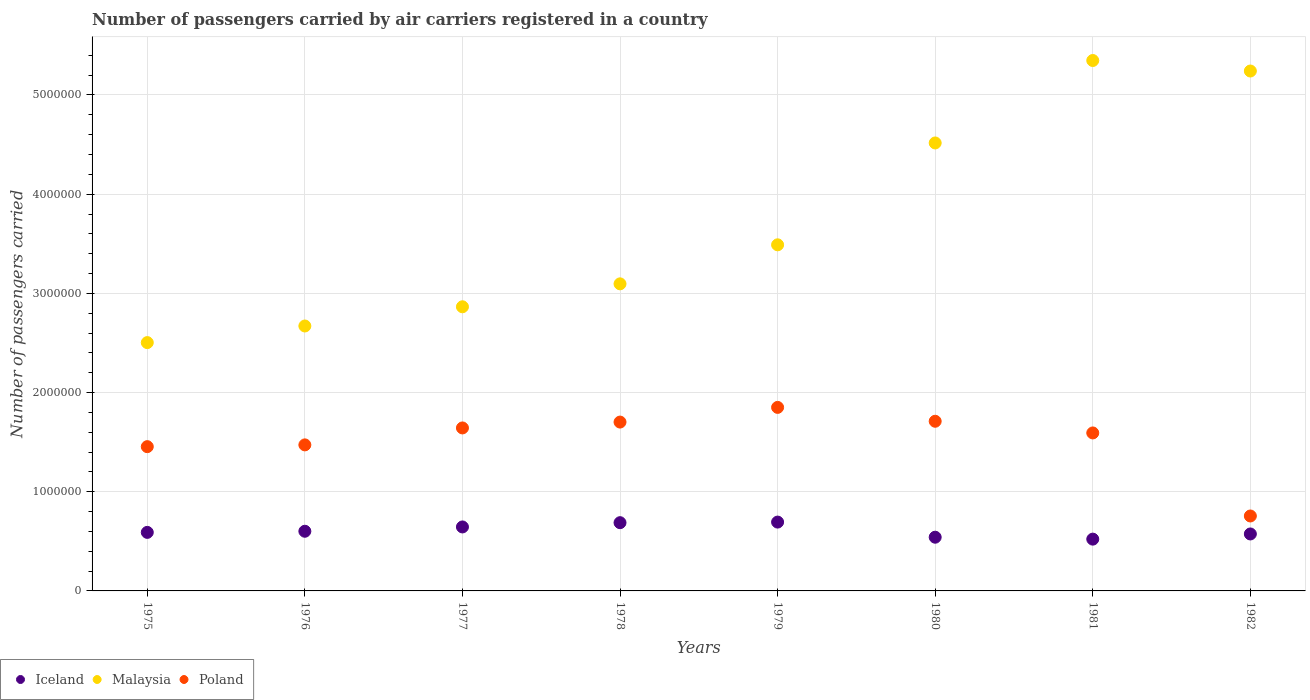What is the number of passengers carried by air carriers in Poland in 1982?
Make the answer very short. 7.56e+05. Across all years, what is the maximum number of passengers carried by air carriers in Poland?
Offer a very short reply. 1.85e+06. Across all years, what is the minimum number of passengers carried by air carriers in Malaysia?
Offer a very short reply. 2.50e+06. In which year was the number of passengers carried by air carriers in Malaysia minimum?
Offer a very short reply. 1975. What is the total number of passengers carried by air carriers in Poland in the graph?
Your answer should be very brief. 1.22e+07. What is the difference between the number of passengers carried by air carriers in Iceland in 1979 and that in 1981?
Make the answer very short. 1.72e+05. What is the difference between the number of passengers carried by air carriers in Malaysia in 1975 and the number of passengers carried by air carriers in Iceland in 1981?
Give a very brief answer. 1.98e+06. What is the average number of passengers carried by air carriers in Malaysia per year?
Offer a very short reply. 3.72e+06. In the year 1979, what is the difference between the number of passengers carried by air carriers in Iceland and number of passengers carried by air carriers in Malaysia?
Provide a short and direct response. -2.80e+06. What is the ratio of the number of passengers carried by air carriers in Poland in 1977 to that in 1979?
Offer a very short reply. 0.89. What is the difference between the highest and the second highest number of passengers carried by air carriers in Iceland?
Offer a very short reply. 6000. What is the difference between the highest and the lowest number of passengers carried by air carriers in Iceland?
Keep it short and to the point. 1.72e+05. Does the number of passengers carried by air carriers in Malaysia monotonically increase over the years?
Provide a short and direct response. No. Is the number of passengers carried by air carriers in Poland strictly greater than the number of passengers carried by air carriers in Iceland over the years?
Offer a terse response. Yes. Is the number of passengers carried by air carriers in Poland strictly less than the number of passengers carried by air carriers in Iceland over the years?
Your response must be concise. No. How many dotlines are there?
Your answer should be very brief. 3. What is the difference between two consecutive major ticks on the Y-axis?
Keep it short and to the point. 1.00e+06. Are the values on the major ticks of Y-axis written in scientific E-notation?
Your response must be concise. No. How many legend labels are there?
Offer a terse response. 3. How are the legend labels stacked?
Your answer should be compact. Horizontal. What is the title of the graph?
Keep it short and to the point. Number of passengers carried by air carriers registered in a country. What is the label or title of the Y-axis?
Make the answer very short. Number of passengers carried. What is the Number of passengers carried of Iceland in 1975?
Your answer should be very brief. 5.90e+05. What is the Number of passengers carried of Malaysia in 1975?
Your answer should be very brief. 2.50e+06. What is the Number of passengers carried in Poland in 1975?
Offer a terse response. 1.45e+06. What is the Number of passengers carried of Iceland in 1976?
Keep it short and to the point. 6.02e+05. What is the Number of passengers carried of Malaysia in 1976?
Provide a succinct answer. 2.67e+06. What is the Number of passengers carried of Poland in 1976?
Keep it short and to the point. 1.47e+06. What is the Number of passengers carried of Iceland in 1977?
Your answer should be very brief. 6.45e+05. What is the Number of passengers carried of Malaysia in 1977?
Offer a very short reply. 2.86e+06. What is the Number of passengers carried of Poland in 1977?
Your answer should be very brief. 1.64e+06. What is the Number of passengers carried of Iceland in 1978?
Give a very brief answer. 6.88e+05. What is the Number of passengers carried of Malaysia in 1978?
Provide a succinct answer. 3.10e+06. What is the Number of passengers carried in Poland in 1978?
Keep it short and to the point. 1.70e+06. What is the Number of passengers carried in Iceland in 1979?
Your answer should be very brief. 6.94e+05. What is the Number of passengers carried in Malaysia in 1979?
Ensure brevity in your answer.  3.49e+06. What is the Number of passengers carried in Poland in 1979?
Offer a terse response. 1.85e+06. What is the Number of passengers carried in Iceland in 1980?
Provide a short and direct response. 5.42e+05. What is the Number of passengers carried in Malaysia in 1980?
Give a very brief answer. 4.52e+06. What is the Number of passengers carried of Poland in 1980?
Your answer should be very brief. 1.71e+06. What is the Number of passengers carried in Iceland in 1981?
Make the answer very short. 5.22e+05. What is the Number of passengers carried of Malaysia in 1981?
Provide a succinct answer. 5.35e+06. What is the Number of passengers carried in Poland in 1981?
Your answer should be compact. 1.59e+06. What is the Number of passengers carried in Iceland in 1982?
Your answer should be very brief. 5.74e+05. What is the Number of passengers carried of Malaysia in 1982?
Your answer should be very brief. 5.24e+06. What is the Number of passengers carried in Poland in 1982?
Provide a succinct answer. 7.56e+05. Across all years, what is the maximum Number of passengers carried in Iceland?
Keep it short and to the point. 6.94e+05. Across all years, what is the maximum Number of passengers carried of Malaysia?
Your response must be concise. 5.35e+06. Across all years, what is the maximum Number of passengers carried of Poland?
Your answer should be very brief. 1.85e+06. Across all years, what is the minimum Number of passengers carried of Iceland?
Provide a short and direct response. 5.22e+05. Across all years, what is the minimum Number of passengers carried in Malaysia?
Your answer should be compact. 2.50e+06. Across all years, what is the minimum Number of passengers carried in Poland?
Give a very brief answer. 7.56e+05. What is the total Number of passengers carried in Iceland in the graph?
Your answer should be compact. 4.86e+06. What is the total Number of passengers carried of Malaysia in the graph?
Your answer should be very brief. 2.97e+07. What is the total Number of passengers carried of Poland in the graph?
Your response must be concise. 1.22e+07. What is the difference between the Number of passengers carried in Iceland in 1975 and that in 1976?
Your answer should be very brief. -1.13e+04. What is the difference between the Number of passengers carried of Malaysia in 1975 and that in 1976?
Make the answer very short. -1.67e+05. What is the difference between the Number of passengers carried of Poland in 1975 and that in 1976?
Ensure brevity in your answer.  -1.79e+04. What is the difference between the Number of passengers carried in Iceland in 1975 and that in 1977?
Your answer should be compact. -5.48e+04. What is the difference between the Number of passengers carried of Malaysia in 1975 and that in 1977?
Provide a succinct answer. -3.61e+05. What is the difference between the Number of passengers carried of Poland in 1975 and that in 1977?
Ensure brevity in your answer.  -1.89e+05. What is the difference between the Number of passengers carried in Iceland in 1975 and that in 1978?
Keep it short and to the point. -9.78e+04. What is the difference between the Number of passengers carried in Malaysia in 1975 and that in 1978?
Your answer should be very brief. -5.92e+05. What is the difference between the Number of passengers carried of Poland in 1975 and that in 1978?
Your response must be concise. -2.48e+05. What is the difference between the Number of passengers carried in Iceland in 1975 and that in 1979?
Provide a short and direct response. -1.04e+05. What is the difference between the Number of passengers carried in Malaysia in 1975 and that in 1979?
Make the answer very short. -9.86e+05. What is the difference between the Number of passengers carried of Poland in 1975 and that in 1979?
Keep it short and to the point. -3.96e+05. What is the difference between the Number of passengers carried in Iceland in 1975 and that in 1980?
Your response must be concise. 4.87e+04. What is the difference between the Number of passengers carried in Malaysia in 1975 and that in 1980?
Provide a succinct answer. -2.01e+06. What is the difference between the Number of passengers carried of Poland in 1975 and that in 1980?
Your response must be concise. -2.56e+05. What is the difference between the Number of passengers carried of Iceland in 1975 and that in 1981?
Your response must be concise. 6.81e+04. What is the difference between the Number of passengers carried of Malaysia in 1975 and that in 1981?
Your answer should be compact. -2.84e+06. What is the difference between the Number of passengers carried in Poland in 1975 and that in 1981?
Your answer should be very brief. -1.38e+05. What is the difference between the Number of passengers carried in Iceland in 1975 and that in 1982?
Provide a short and direct response. 1.59e+04. What is the difference between the Number of passengers carried of Malaysia in 1975 and that in 1982?
Provide a short and direct response. -2.74e+06. What is the difference between the Number of passengers carried in Poland in 1975 and that in 1982?
Give a very brief answer. 6.99e+05. What is the difference between the Number of passengers carried of Iceland in 1976 and that in 1977?
Your response must be concise. -4.35e+04. What is the difference between the Number of passengers carried in Malaysia in 1976 and that in 1977?
Offer a terse response. -1.94e+05. What is the difference between the Number of passengers carried of Poland in 1976 and that in 1977?
Your response must be concise. -1.71e+05. What is the difference between the Number of passengers carried in Iceland in 1976 and that in 1978?
Offer a terse response. -8.65e+04. What is the difference between the Number of passengers carried of Malaysia in 1976 and that in 1978?
Your response must be concise. -4.25e+05. What is the difference between the Number of passengers carried of Poland in 1976 and that in 1978?
Your response must be concise. -2.30e+05. What is the difference between the Number of passengers carried in Iceland in 1976 and that in 1979?
Your answer should be very brief. -9.25e+04. What is the difference between the Number of passengers carried in Malaysia in 1976 and that in 1979?
Provide a succinct answer. -8.18e+05. What is the difference between the Number of passengers carried of Poland in 1976 and that in 1979?
Your answer should be very brief. -3.78e+05. What is the difference between the Number of passengers carried in Malaysia in 1976 and that in 1980?
Provide a short and direct response. -1.85e+06. What is the difference between the Number of passengers carried of Poland in 1976 and that in 1980?
Offer a very short reply. -2.38e+05. What is the difference between the Number of passengers carried in Iceland in 1976 and that in 1981?
Keep it short and to the point. 7.94e+04. What is the difference between the Number of passengers carried in Malaysia in 1976 and that in 1981?
Provide a short and direct response. -2.68e+06. What is the difference between the Number of passengers carried of Poland in 1976 and that in 1981?
Your response must be concise. -1.20e+05. What is the difference between the Number of passengers carried of Iceland in 1976 and that in 1982?
Your answer should be compact. 2.72e+04. What is the difference between the Number of passengers carried of Malaysia in 1976 and that in 1982?
Make the answer very short. -2.57e+06. What is the difference between the Number of passengers carried of Poland in 1976 and that in 1982?
Give a very brief answer. 7.17e+05. What is the difference between the Number of passengers carried in Iceland in 1977 and that in 1978?
Ensure brevity in your answer.  -4.30e+04. What is the difference between the Number of passengers carried in Malaysia in 1977 and that in 1978?
Give a very brief answer. -2.31e+05. What is the difference between the Number of passengers carried in Poland in 1977 and that in 1978?
Offer a very short reply. -5.91e+04. What is the difference between the Number of passengers carried of Iceland in 1977 and that in 1979?
Your answer should be very brief. -4.90e+04. What is the difference between the Number of passengers carried of Malaysia in 1977 and that in 1979?
Make the answer very short. -6.25e+05. What is the difference between the Number of passengers carried of Poland in 1977 and that in 1979?
Give a very brief answer. -2.07e+05. What is the difference between the Number of passengers carried in Iceland in 1977 and that in 1980?
Ensure brevity in your answer.  1.04e+05. What is the difference between the Number of passengers carried of Malaysia in 1977 and that in 1980?
Give a very brief answer. -1.65e+06. What is the difference between the Number of passengers carried of Poland in 1977 and that in 1980?
Your answer should be compact. -6.73e+04. What is the difference between the Number of passengers carried in Iceland in 1977 and that in 1981?
Offer a terse response. 1.23e+05. What is the difference between the Number of passengers carried of Malaysia in 1977 and that in 1981?
Provide a short and direct response. -2.48e+06. What is the difference between the Number of passengers carried of Poland in 1977 and that in 1981?
Ensure brevity in your answer.  5.04e+04. What is the difference between the Number of passengers carried in Iceland in 1977 and that in 1982?
Ensure brevity in your answer.  7.07e+04. What is the difference between the Number of passengers carried in Malaysia in 1977 and that in 1982?
Your answer should be compact. -2.38e+06. What is the difference between the Number of passengers carried in Poland in 1977 and that in 1982?
Your answer should be compact. 8.88e+05. What is the difference between the Number of passengers carried in Iceland in 1978 and that in 1979?
Offer a very short reply. -6000. What is the difference between the Number of passengers carried in Malaysia in 1978 and that in 1979?
Offer a very short reply. -3.94e+05. What is the difference between the Number of passengers carried in Poland in 1978 and that in 1979?
Provide a succinct answer. -1.48e+05. What is the difference between the Number of passengers carried of Iceland in 1978 and that in 1980?
Your answer should be very brief. 1.46e+05. What is the difference between the Number of passengers carried of Malaysia in 1978 and that in 1980?
Offer a very short reply. -1.42e+06. What is the difference between the Number of passengers carried of Poland in 1978 and that in 1980?
Offer a very short reply. -8200. What is the difference between the Number of passengers carried in Iceland in 1978 and that in 1981?
Ensure brevity in your answer.  1.66e+05. What is the difference between the Number of passengers carried in Malaysia in 1978 and that in 1981?
Give a very brief answer. -2.25e+06. What is the difference between the Number of passengers carried of Poland in 1978 and that in 1981?
Offer a terse response. 1.10e+05. What is the difference between the Number of passengers carried of Iceland in 1978 and that in 1982?
Offer a very short reply. 1.14e+05. What is the difference between the Number of passengers carried in Malaysia in 1978 and that in 1982?
Ensure brevity in your answer.  -2.15e+06. What is the difference between the Number of passengers carried in Poland in 1978 and that in 1982?
Offer a terse response. 9.47e+05. What is the difference between the Number of passengers carried of Iceland in 1979 and that in 1980?
Provide a succinct answer. 1.52e+05. What is the difference between the Number of passengers carried of Malaysia in 1979 and that in 1980?
Make the answer very short. -1.03e+06. What is the difference between the Number of passengers carried of Poland in 1979 and that in 1980?
Keep it short and to the point. 1.40e+05. What is the difference between the Number of passengers carried in Iceland in 1979 and that in 1981?
Provide a succinct answer. 1.72e+05. What is the difference between the Number of passengers carried of Malaysia in 1979 and that in 1981?
Provide a succinct answer. -1.86e+06. What is the difference between the Number of passengers carried of Poland in 1979 and that in 1981?
Offer a terse response. 2.58e+05. What is the difference between the Number of passengers carried in Iceland in 1979 and that in 1982?
Provide a succinct answer. 1.20e+05. What is the difference between the Number of passengers carried in Malaysia in 1979 and that in 1982?
Give a very brief answer. -1.75e+06. What is the difference between the Number of passengers carried in Poland in 1979 and that in 1982?
Keep it short and to the point. 1.09e+06. What is the difference between the Number of passengers carried of Iceland in 1980 and that in 1981?
Ensure brevity in your answer.  1.94e+04. What is the difference between the Number of passengers carried in Malaysia in 1980 and that in 1981?
Provide a succinct answer. -8.31e+05. What is the difference between the Number of passengers carried in Poland in 1980 and that in 1981?
Your response must be concise. 1.18e+05. What is the difference between the Number of passengers carried in Iceland in 1980 and that in 1982?
Keep it short and to the point. -3.28e+04. What is the difference between the Number of passengers carried in Malaysia in 1980 and that in 1982?
Your answer should be very brief. -7.25e+05. What is the difference between the Number of passengers carried in Poland in 1980 and that in 1982?
Provide a succinct answer. 9.55e+05. What is the difference between the Number of passengers carried in Iceland in 1981 and that in 1982?
Ensure brevity in your answer.  -5.22e+04. What is the difference between the Number of passengers carried in Malaysia in 1981 and that in 1982?
Your answer should be compact. 1.06e+05. What is the difference between the Number of passengers carried in Poland in 1981 and that in 1982?
Your response must be concise. 8.37e+05. What is the difference between the Number of passengers carried of Iceland in 1975 and the Number of passengers carried of Malaysia in 1976?
Your answer should be very brief. -2.08e+06. What is the difference between the Number of passengers carried in Iceland in 1975 and the Number of passengers carried in Poland in 1976?
Offer a terse response. -8.82e+05. What is the difference between the Number of passengers carried in Malaysia in 1975 and the Number of passengers carried in Poland in 1976?
Keep it short and to the point. 1.03e+06. What is the difference between the Number of passengers carried in Iceland in 1975 and the Number of passengers carried in Malaysia in 1977?
Ensure brevity in your answer.  -2.27e+06. What is the difference between the Number of passengers carried of Iceland in 1975 and the Number of passengers carried of Poland in 1977?
Provide a short and direct response. -1.05e+06. What is the difference between the Number of passengers carried of Malaysia in 1975 and the Number of passengers carried of Poland in 1977?
Give a very brief answer. 8.60e+05. What is the difference between the Number of passengers carried in Iceland in 1975 and the Number of passengers carried in Malaysia in 1978?
Make the answer very short. -2.51e+06. What is the difference between the Number of passengers carried in Iceland in 1975 and the Number of passengers carried in Poland in 1978?
Your answer should be very brief. -1.11e+06. What is the difference between the Number of passengers carried in Malaysia in 1975 and the Number of passengers carried in Poland in 1978?
Offer a very short reply. 8.01e+05. What is the difference between the Number of passengers carried in Iceland in 1975 and the Number of passengers carried in Malaysia in 1979?
Offer a terse response. -2.90e+06. What is the difference between the Number of passengers carried of Iceland in 1975 and the Number of passengers carried of Poland in 1979?
Make the answer very short. -1.26e+06. What is the difference between the Number of passengers carried in Malaysia in 1975 and the Number of passengers carried in Poland in 1979?
Ensure brevity in your answer.  6.53e+05. What is the difference between the Number of passengers carried of Iceland in 1975 and the Number of passengers carried of Malaysia in 1980?
Ensure brevity in your answer.  -3.93e+06. What is the difference between the Number of passengers carried of Iceland in 1975 and the Number of passengers carried of Poland in 1980?
Make the answer very short. -1.12e+06. What is the difference between the Number of passengers carried in Malaysia in 1975 and the Number of passengers carried in Poland in 1980?
Your answer should be very brief. 7.93e+05. What is the difference between the Number of passengers carried in Iceland in 1975 and the Number of passengers carried in Malaysia in 1981?
Your answer should be very brief. -4.76e+06. What is the difference between the Number of passengers carried in Iceland in 1975 and the Number of passengers carried in Poland in 1981?
Your answer should be compact. -1.00e+06. What is the difference between the Number of passengers carried in Malaysia in 1975 and the Number of passengers carried in Poland in 1981?
Make the answer very short. 9.11e+05. What is the difference between the Number of passengers carried in Iceland in 1975 and the Number of passengers carried in Malaysia in 1982?
Give a very brief answer. -4.65e+06. What is the difference between the Number of passengers carried of Iceland in 1975 and the Number of passengers carried of Poland in 1982?
Offer a very short reply. -1.65e+05. What is the difference between the Number of passengers carried of Malaysia in 1975 and the Number of passengers carried of Poland in 1982?
Ensure brevity in your answer.  1.75e+06. What is the difference between the Number of passengers carried of Iceland in 1976 and the Number of passengers carried of Malaysia in 1977?
Provide a succinct answer. -2.26e+06. What is the difference between the Number of passengers carried of Iceland in 1976 and the Number of passengers carried of Poland in 1977?
Keep it short and to the point. -1.04e+06. What is the difference between the Number of passengers carried of Malaysia in 1976 and the Number of passengers carried of Poland in 1977?
Your response must be concise. 1.03e+06. What is the difference between the Number of passengers carried in Iceland in 1976 and the Number of passengers carried in Malaysia in 1978?
Make the answer very short. -2.49e+06. What is the difference between the Number of passengers carried of Iceland in 1976 and the Number of passengers carried of Poland in 1978?
Your answer should be very brief. -1.10e+06. What is the difference between the Number of passengers carried in Malaysia in 1976 and the Number of passengers carried in Poland in 1978?
Your answer should be very brief. 9.69e+05. What is the difference between the Number of passengers carried in Iceland in 1976 and the Number of passengers carried in Malaysia in 1979?
Your answer should be very brief. -2.89e+06. What is the difference between the Number of passengers carried in Iceland in 1976 and the Number of passengers carried in Poland in 1979?
Your response must be concise. -1.25e+06. What is the difference between the Number of passengers carried of Malaysia in 1976 and the Number of passengers carried of Poland in 1979?
Provide a short and direct response. 8.21e+05. What is the difference between the Number of passengers carried in Iceland in 1976 and the Number of passengers carried in Malaysia in 1980?
Provide a short and direct response. -3.91e+06. What is the difference between the Number of passengers carried of Iceland in 1976 and the Number of passengers carried of Poland in 1980?
Offer a very short reply. -1.11e+06. What is the difference between the Number of passengers carried of Malaysia in 1976 and the Number of passengers carried of Poland in 1980?
Your answer should be very brief. 9.60e+05. What is the difference between the Number of passengers carried of Iceland in 1976 and the Number of passengers carried of Malaysia in 1981?
Your answer should be very brief. -4.75e+06. What is the difference between the Number of passengers carried in Iceland in 1976 and the Number of passengers carried in Poland in 1981?
Offer a very short reply. -9.91e+05. What is the difference between the Number of passengers carried in Malaysia in 1976 and the Number of passengers carried in Poland in 1981?
Provide a short and direct response. 1.08e+06. What is the difference between the Number of passengers carried of Iceland in 1976 and the Number of passengers carried of Malaysia in 1982?
Provide a succinct answer. -4.64e+06. What is the difference between the Number of passengers carried of Iceland in 1976 and the Number of passengers carried of Poland in 1982?
Your response must be concise. -1.54e+05. What is the difference between the Number of passengers carried in Malaysia in 1976 and the Number of passengers carried in Poland in 1982?
Make the answer very short. 1.92e+06. What is the difference between the Number of passengers carried of Iceland in 1977 and the Number of passengers carried of Malaysia in 1978?
Your response must be concise. -2.45e+06. What is the difference between the Number of passengers carried in Iceland in 1977 and the Number of passengers carried in Poland in 1978?
Give a very brief answer. -1.06e+06. What is the difference between the Number of passengers carried of Malaysia in 1977 and the Number of passengers carried of Poland in 1978?
Ensure brevity in your answer.  1.16e+06. What is the difference between the Number of passengers carried of Iceland in 1977 and the Number of passengers carried of Malaysia in 1979?
Make the answer very short. -2.84e+06. What is the difference between the Number of passengers carried of Iceland in 1977 and the Number of passengers carried of Poland in 1979?
Provide a short and direct response. -1.21e+06. What is the difference between the Number of passengers carried in Malaysia in 1977 and the Number of passengers carried in Poland in 1979?
Provide a succinct answer. 1.01e+06. What is the difference between the Number of passengers carried in Iceland in 1977 and the Number of passengers carried in Malaysia in 1980?
Make the answer very short. -3.87e+06. What is the difference between the Number of passengers carried of Iceland in 1977 and the Number of passengers carried of Poland in 1980?
Your response must be concise. -1.07e+06. What is the difference between the Number of passengers carried in Malaysia in 1977 and the Number of passengers carried in Poland in 1980?
Keep it short and to the point. 1.15e+06. What is the difference between the Number of passengers carried in Iceland in 1977 and the Number of passengers carried in Malaysia in 1981?
Give a very brief answer. -4.70e+06. What is the difference between the Number of passengers carried of Iceland in 1977 and the Number of passengers carried of Poland in 1981?
Make the answer very short. -9.48e+05. What is the difference between the Number of passengers carried in Malaysia in 1977 and the Number of passengers carried in Poland in 1981?
Offer a terse response. 1.27e+06. What is the difference between the Number of passengers carried of Iceland in 1977 and the Number of passengers carried of Malaysia in 1982?
Offer a terse response. -4.60e+06. What is the difference between the Number of passengers carried of Iceland in 1977 and the Number of passengers carried of Poland in 1982?
Offer a terse response. -1.10e+05. What is the difference between the Number of passengers carried in Malaysia in 1977 and the Number of passengers carried in Poland in 1982?
Your response must be concise. 2.11e+06. What is the difference between the Number of passengers carried of Iceland in 1978 and the Number of passengers carried of Malaysia in 1979?
Your answer should be compact. -2.80e+06. What is the difference between the Number of passengers carried of Iceland in 1978 and the Number of passengers carried of Poland in 1979?
Offer a terse response. -1.16e+06. What is the difference between the Number of passengers carried in Malaysia in 1978 and the Number of passengers carried in Poland in 1979?
Your answer should be compact. 1.25e+06. What is the difference between the Number of passengers carried in Iceland in 1978 and the Number of passengers carried in Malaysia in 1980?
Provide a succinct answer. -3.83e+06. What is the difference between the Number of passengers carried of Iceland in 1978 and the Number of passengers carried of Poland in 1980?
Give a very brief answer. -1.02e+06. What is the difference between the Number of passengers carried in Malaysia in 1978 and the Number of passengers carried in Poland in 1980?
Make the answer very short. 1.39e+06. What is the difference between the Number of passengers carried of Iceland in 1978 and the Number of passengers carried of Malaysia in 1981?
Your answer should be compact. -4.66e+06. What is the difference between the Number of passengers carried in Iceland in 1978 and the Number of passengers carried in Poland in 1981?
Provide a short and direct response. -9.05e+05. What is the difference between the Number of passengers carried of Malaysia in 1978 and the Number of passengers carried of Poland in 1981?
Ensure brevity in your answer.  1.50e+06. What is the difference between the Number of passengers carried of Iceland in 1978 and the Number of passengers carried of Malaysia in 1982?
Your response must be concise. -4.55e+06. What is the difference between the Number of passengers carried in Iceland in 1978 and the Number of passengers carried in Poland in 1982?
Make the answer very short. -6.75e+04. What is the difference between the Number of passengers carried in Malaysia in 1978 and the Number of passengers carried in Poland in 1982?
Ensure brevity in your answer.  2.34e+06. What is the difference between the Number of passengers carried of Iceland in 1979 and the Number of passengers carried of Malaysia in 1980?
Provide a short and direct response. -3.82e+06. What is the difference between the Number of passengers carried in Iceland in 1979 and the Number of passengers carried in Poland in 1980?
Your response must be concise. -1.02e+06. What is the difference between the Number of passengers carried in Malaysia in 1979 and the Number of passengers carried in Poland in 1980?
Provide a succinct answer. 1.78e+06. What is the difference between the Number of passengers carried of Iceland in 1979 and the Number of passengers carried of Malaysia in 1981?
Your response must be concise. -4.65e+06. What is the difference between the Number of passengers carried of Iceland in 1979 and the Number of passengers carried of Poland in 1981?
Offer a very short reply. -8.99e+05. What is the difference between the Number of passengers carried of Malaysia in 1979 and the Number of passengers carried of Poland in 1981?
Give a very brief answer. 1.90e+06. What is the difference between the Number of passengers carried of Iceland in 1979 and the Number of passengers carried of Malaysia in 1982?
Provide a short and direct response. -4.55e+06. What is the difference between the Number of passengers carried in Iceland in 1979 and the Number of passengers carried in Poland in 1982?
Your answer should be very brief. -6.15e+04. What is the difference between the Number of passengers carried in Malaysia in 1979 and the Number of passengers carried in Poland in 1982?
Your answer should be very brief. 2.73e+06. What is the difference between the Number of passengers carried of Iceland in 1980 and the Number of passengers carried of Malaysia in 1981?
Your answer should be very brief. -4.81e+06. What is the difference between the Number of passengers carried in Iceland in 1980 and the Number of passengers carried in Poland in 1981?
Offer a very short reply. -1.05e+06. What is the difference between the Number of passengers carried in Malaysia in 1980 and the Number of passengers carried in Poland in 1981?
Offer a very short reply. 2.92e+06. What is the difference between the Number of passengers carried of Iceland in 1980 and the Number of passengers carried of Malaysia in 1982?
Give a very brief answer. -4.70e+06. What is the difference between the Number of passengers carried of Iceland in 1980 and the Number of passengers carried of Poland in 1982?
Ensure brevity in your answer.  -2.14e+05. What is the difference between the Number of passengers carried of Malaysia in 1980 and the Number of passengers carried of Poland in 1982?
Give a very brief answer. 3.76e+06. What is the difference between the Number of passengers carried in Iceland in 1981 and the Number of passengers carried in Malaysia in 1982?
Offer a terse response. -4.72e+06. What is the difference between the Number of passengers carried in Iceland in 1981 and the Number of passengers carried in Poland in 1982?
Make the answer very short. -2.33e+05. What is the difference between the Number of passengers carried in Malaysia in 1981 and the Number of passengers carried in Poland in 1982?
Provide a short and direct response. 4.59e+06. What is the average Number of passengers carried of Iceland per year?
Ensure brevity in your answer.  6.07e+05. What is the average Number of passengers carried of Malaysia per year?
Provide a succinct answer. 3.72e+06. What is the average Number of passengers carried of Poland per year?
Your answer should be very brief. 1.52e+06. In the year 1975, what is the difference between the Number of passengers carried of Iceland and Number of passengers carried of Malaysia?
Your answer should be compact. -1.91e+06. In the year 1975, what is the difference between the Number of passengers carried of Iceland and Number of passengers carried of Poland?
Your answer should be compact. -8.64e+05. In the year 1975, what is the difference between the Number of passengers carried in Malaysia and Number of passengers carried in Poland?
Offer a very short reply. 1.05e+06. In the year 1976, what is the difference between the Number of passengers carried in Iceland and Number of passengers carried in Malaysia?
Your response must be concise. -2.07e+06. In the year 1976, what is the difference between the Number of passengers carried of Iceland and Number of passengers carried of Poland?
Your response must be concise. -8.71e+05. In the year 1976, what is the difference between the Number of passengers carried of Malaysia and Number of passengers carried of Poland?
Offer a very short reply. 1.20e+06. In the year 1977, what is the difference between the Number of passengers carried of Iceland and Number of passengers carried of Malaysia?
Make the answer very short. -2.22e+06. In the year 1977, what is the difference between the Number of passengers carried of Iceland and Number of passengers carried of Poland?
Offer a terse response. -9.98e+05. In the year 1977, what is the difference between the Number of passengers carried in Malaysia and Number of passengers carried in Poland?
Offer a very short reply. 1.22e+06. In the year 1978, what is the difference between the Number of passengers carried of Iceland and Number of passengers carried of Malaysia?
Provide a short and direct response. -2.41e+06. In the year 1978, what is the difference between the Number of passengers carried in Iceland and Number of passengers carried in Poland?
Keep it short and to the point. -1.01e+06. In the year 1978, what is the difference between the Number of passengers carried in Malaysia and Number of passengers carried in Poland?
Provide a succinct answer. 1.39e+06. In the year 1979, what is the difference between the Number of passengers carried of Iceland and Number of passengers carried of Malaysia?
Provide a succinct answer. -2.80e+06. In the year 1979, what is the difference between the Number of passengers carried in Iceland and Number of passengers carried in Poland?
Offer a terse response. -1.16e+06. In the year 1979, what is the difference between the Number of passengers carried in Malaysia and Number of passengers carried in Poland?
Provide a short and direct response. 1.64e+06. In the year 1980, what is the difference between the Number of passengers carried in Iceland and Number of passengers carried in Malaysia?
Your answer should be compact. -3.97e+06. In the year 1980, what is the difference between the Number of passengers carried in Iceland and Number of passengers carried in Poland?
Keep it short and to the point. -1.17e+06. In the year 1980, what is the difference between the Number of passengers carried of Malaysia and Number of passengers carried of Poland?
Offer a very short reply. 2.81e+06. In the year 1981, what is the difference between the Number of passengers carried in Iceland and Number of passengers carried in Malaysia?
Offer a terse response. -4.83e+06. In the year 1981, what is the difference between the Number of passengers carried in Iceland and Number of passengers carried in Poland?
Provide a short and direct response. -1.07e+06. In the year 1981, what is the difference between the Number of passengers carried in Malaysia and Number of passengers carried in Poland?
Offer a very short reply. 3.75e+06. In the year 1982, what is the difference between the Number of passengers carried in Iceland and Number of passengers carried in Malaysia?
Offer a very short reply. -4.67e+06. In the year 1982, what is the difference between the Number of passengers carried in Iceland and Number of passengers carried in Poland?
Your answer should be very brief. -1.81e+05. In the year 1982, what is the difference between the Number of passengers carried of Malaysia and Number of passengers carried of Poland?
Provide a short and direct response. 4.49e+06. What is the ratio of the Number of passengers carried in Iceland in 1975 to that in 1976?
Make the answer very short. 0.98. What is the ratio of the Number of passengers carried of Malaysia in 1975 to that in 1976?
Your answer should be compact. 0.94. What is the ratio of the Number of passengers carried in Poland in 1975 to that in 1976?
Give a very brief answer. 0.99. What is the ratio of the Number of passengers carried of Iceland in 1975 to that in 1977?
Offer a very short reply. 0.92. What is the ratio of the Number of passengers carried of Malaysia in 1975 to that in 1977?
Make the answer very short. 0.87. What is the ratio of the Number of passengers carried of Poland in 1975 to that in 1977?
Provide a short and direct response. 0.89. What is the ratio of the Number of passengers carried in Iceland in 1975 to that in 1978?
Give a very brief answer. 0.86. What is the ratio of the Number of passengers carried of Malaysia in 1975 to that in 1978?
Provide a succinct answer. 0.81. What is the ratio of the Number of passengers carried in Poland in 1975 to that in 1978?
Ensure brevity in your answer.  0.85. What is the ratio of the Number of passengers carried of Iceland in 1975 to that in 1979?
Give a very brief answer. 0.85. What is the ratio of the Number of passengers carried of Malaysia in 1975 to that in 1979?
Keep it short and to the point. 0.72. What is the ratio of the Number of passengers carried in Poland in 1975 to that in 1979?
Keep it short and to the point. 0.79. What is the ratio of the Number of passengers carried of Iceland in 1975 to that in 1980?
Provide a short and direct response. 1.09. What is the ratio of the Number of passengers carried of Malaysia in 1975 to that in 1980?
Your answer should be compact. 0.55. What is the ratio of the Number of passengers carried of Poland in 1975 to that in 1980?
Give a very brief answer. 0.85. What is the ratio of the Number of passengers carried of Iceland in 1975 to that in 1981?
Provide a short and direct response. 1.13. What is the ratio of the Number of passengers carried in Malaysia in 1975 to that in 1981?
Your answer should be compact. 0.47. What is the ratio of the Number of passengers carried in Poland in 1975 to that in 1981?
Your answer should be very brief. 0.91. What is the ratio of the Number of passengers carried in Iceland in 1975 to that in 1982?
Ensure brevity in your answer.  1.03. What is the ratio of the Number of passengers carried of Malaysia in 1975 to that in 1982?
Offer a terse response. 0.48. What is the ratio of the Number of passengers carried of Poland in 1975 to that in 1982?
Make the answer very short. 1.93. What is the ratio of the Number of passengers carried of Iceland in 1976 to that in 1977?
Make the answer very short. 0.93. What is the ratio of the Number of passengers carried in Malaysia in 1976 to that in 1977?
Provide a succinct answer. 0.93. What is the ratio of the Number of passengers carried of Poland in 1976 to that in 1977?
Your answer should be very brief. 0.9. What is the ratio of the Number of passengers carried of Iceland in 1976 to that in 1978?
Offer a terse response. 0.87. What is the ratio of the Number of passengers carried in Malaysia in 1976 to that in 1978?
Your response must be concise. 0.86. What is the ratio of the Number of passengers carried of Poland in 1976 to that in 1978?
Your response must be concise. 0.86. What is the ratio of the Number of passengers carried of Iceland in 1976 to that in 1979?
Offer a terse response. 0.87. What is the ratio of the Number of passengers carried in Malaysia in 1976 to that in 1979?
Ensure brevity in your answer.  0.77. What is the ratio of the Number of passengers carried of Poland in 1976 to that in 1979?
Offer a terse response. 0.8. What is the ratio of the Number of passengers carried in Iceland in 1976 to that in 1980?
Keep it short and to the point. 1.11. What is the ratio of the Number of passengers carried of Malaysia in 1976 to that in 1980?
Provide a succinct answer. 0.59. What is the ratio of the Number of passengers carried in Poland in 1976 to that in 1980?
Your response must be concise. 0.86. What is the ratio of the Number of passengers carried of Iceland in 1976 to that in 1981?
Provide a succinct answer. 1.15. What is the ratio of the Number of passengers carried in Malaysia in 1976 to that in 1981?
Provide a succinct answer. 0.5. What is the ratio of the Number of passengers carried of Poland in 1976 to that in 1981?
Ensure brevity in your answer.  0.92. What is the ratio of the Number of passengers carried in Iceland in 1976 to that in 1982?
Provide a succinct answer. 1.05. What is the ratio of the Number of passengers carried of Malaysia in 1976 to that in 1982?
Your answer should be very brief. 0.51. What is the ratio of the Number of passengers carried in Poland in 1976 to that in 1982?
Your answer should be compact. 1.95. What is the ratio of the Number of passengers carried in Iceland in 1977 to that in 1978?
Offer a very short reply. 0.94. What is the ratio of the Number of passengers carried of Malaysia in 1977 to that in 1978?
Offer a terse response. 0.93. What is the ratio of the Number of passengers carried in Poland in 1977 to that in 1978?
Offer a very short reply. 0.97. What is the ratio of the Number of passengers carried of Iceland in 1977 to that in 1979?
Provide a short and direct response. 0.93. What is the ratio of the Number of passengers carried in Malaysia in 1977 to that in 1979?
Offer a very short reply. 0.82. What is the ratio of the Number of passengers carried of Poland in 1977 to that in 1979?
Your answer should be compact. 0.89. What is the ratio of the Number of passengers carried of Iceland in 1977 to that in 1980?
Provide a succinct answer. 1.19. What is the ratio of the Number of passengers carried in Malaysia in 1977 to that in 1980?
Offer a very short reply. 0.63. What is the ratio of the Number of passengers carried in Poland in 1977 to that in 1980?
Your answer should be very brief. 0.96. What is the ratio of the Number of passengers carried of Iceland in 1977 to that in 1981?
Give a very brief answer. 1.24. What is the ratio of the Number of passengers carried of Malaysia in 1977 to that in 1981?
Give a very brief answer. 0.54. What is the ratio of the Number of passengers carried in Poland in 1977 to that in 1981?
Your answer should be very brief. 1.03. What is the ratio of the Number of passengers carried in Iceland in 1977 to that in 1982?
Your answer should be very brief. 1.12. What is the ratio of the Number of passengers carried of Malaysia in 1977 to that in 1982?
Provide a short and direct response. 0.55. What is the ratio of the Number of passengers carried of Poland in 1977 to that in 1982?
Offer a very short reply. 2.17. What is the ratio of the Number of passengers carried of Malaysia in 1978 to that in 1979?
Offer a terse response. 0.89. What is the ratio of the Number of passengers carried of Poland in 1978 to that in 1979?
Your answer should be very brief. 0.92. What is the ratio of the Number of passengers carried of Iceland in 1978 to that in 1980?
Your answer should be very brief. 1.27. What is the ratio of the Number of passengers carried in Malaysia in 1978 to that in 1980?
Provide a short and direct response. 0.69. What is the ratio of the Number of passengers carried in Iceland in 1978 to that in 1981?
Your response must be concise. 1.32. What is the ratio of the Number of passengers carried of Malaysia in 1978 to that in 1981?
Offer a very short reply. 0.58. What is the ratio of the Number of passengers carried of Poland in 1978 to that in 1981?
Your answer should be compact. 1.07. What is the ratio of the Number of passengers carried in Iceland in 1978 to that in 1982?
Provide a succinct answer. 1.2. What is the ratio of the Number of passengers carried in Malaysia in 1978 to that in 1982?
Make the answer very short. 0.59. What is the ratio of the Number of passengers carried in Poland in 1978 to that in 1982?
Provide a succinct answer. 2.25. What is the ratio of the Number of passengers carried in Iceland in 1979 to that in 1980?
Offer a very short reply. 1.28. What is the ratio of the Number of passengers carried in Malaysia in 1979 to that in 1980?
Offer a terse response. 0.77. What is the ratio of the Number of passengers carried in Poland in 1979 to that in 1980?
Your response must be concise. 1.08. What is the ratio of the Number of passengers carried of Iceland in 1979 to that in 1981?
Your response must be concise. 1.33. What is the ratio of the Number of passengers carried in Malaysia in 1979 to that in 1981?
Provide a short and direct response. 0.65. What is the ratio of the Number of passengers carried of Poland in 1979 to that in 1981?
Make the answer very short. 1.16. What is the ratio of the Number of passengers carried in Iceland in 1979 to that in 1982?
Make the answer very short. 1.21. What is the ratio of the Number of passengers carried of Malaysia in 1979 to that in 1982?
Provide a short and direct response. 0.67. What is the ratio of the Number of passengers carried of Poland in 1979 to that in 1982?
Give a very brief answer. 2.45. What is the ratio of the Number of passengers carried of Iceland in 1980 to that in 1981?
Your response must be concise. 1.04. What is the ratio of the Number of passengers carried of Malaysia in 1980 to that in 1981?
Offer a very short reply. 0.84. What is the ratio of the Number of passengers carried of Poland in 1980 to that in 1981?
Provide a succinct answer. 1.07. What is the ratio of the Number of passengers carried of Iceland in 1980 to that in 1982?
Provide a succinct answer. 0.94. What is the ratio of the Number of passengers carried in Malaysia in 1980 to that in 1982?
Ensure brevity in your answer.  0.86. What is the ratio of the Number of passengers carried of Poland in 1980 to that in 1982?
Ensure brevity in your answer.  2.26. What is the ratio of the Number of passengers carried of Malaysia in 1981 to that in 1982?
Your answer should be compact. 1.02. What is the ratio of the Number of passengers carried of Poland in 1981 to that in 1982?
Make the answer very short. 2.11. What is the difference between the highest and the second highest Number of passengers carried of Iceland?
Offer a very short reply. 6000. What is the difference between the highest and the second highest Number of passengers carried of Malaysia?
Provide a succinct answer. 1.06e+05. What is the difference between the highest and the second highest Number of passengers carried of Poland?
Offer a terse response. 1.40e+05. What is the difference between the highest and the lowest Number of passengers carried in Iceland?
Provide a short and direct response. 1.72e+05. What is the difference between the highest and the lowest Number of passengers carried of Malaysia?
Ensure brevity in your answer.  2.84e+06. What is the difference between the highest and the lowest Number of passengers carried of Poland?
Your answer should be very brief. 1.09e+06. 